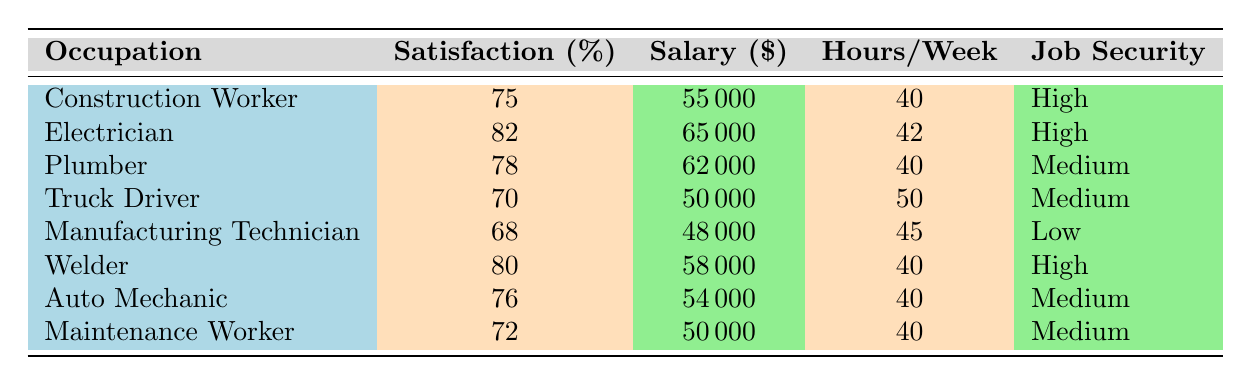What is the job satisfaction rating for Electricians? The table indicates that the job satisfaction rating for Electricians is listed directly as 82%.
Answer: 82% Which occupation has the highest salary according to the table? By looking at the salary column, Electricians have the highest salary listed at $65,000.
Answer: Electrician Is the job security for Maintenance Workers classified as High? The table shows that the job security for Maintenance Workers is categorized as Medium, not High.
Answer: No What is the average job satisfaction rating for all listed occupations? To find the average, we sum the job satisfaction ratings: (75 + 82 + 78 + 70 + 68 + 80 + 76 + 72) = 601. There are 8 occupations, so the average is 601 / 8 = 75.125, approximately 75.13%.
Answer: 75.13% Which occupations have a job satisfaction rating above 75%? Looking at the job satisfaction ratings, the occupations above 75% are Electrician (82%), Welder (80%), and Plumber (78%).
Answer: Electrician, Welder, Plumber How many hours per week do Truck Drivers work, and how does this compare to Auto Mechanics? The table shows Truck Drivers work 50 hours per week, while Auto Mechanics work 40 hours per week. The difference is Truck Drivers work 10 more hours than Auto Mechanics.
Answer: Truck Drivers work 50 hours; 10 hours more than Auto Mechanics What is the job satisfaction rating difference between Welder and Manufacturing Technician? The ratings indicate that Welders have a satisfaction rating of 80% and Manufacturing Technicians have 68%. The difference is 80 - 68 = 12%.
Answer: 12% Are there more occupations with High job security than Low job security? The table lists 4 occupations with High job security (Construction Worker, Electrician, Welder) and 1 occupation with Low job security (Manufacturing Technician), confirming that there are more with High job security.
Answer: Yes 